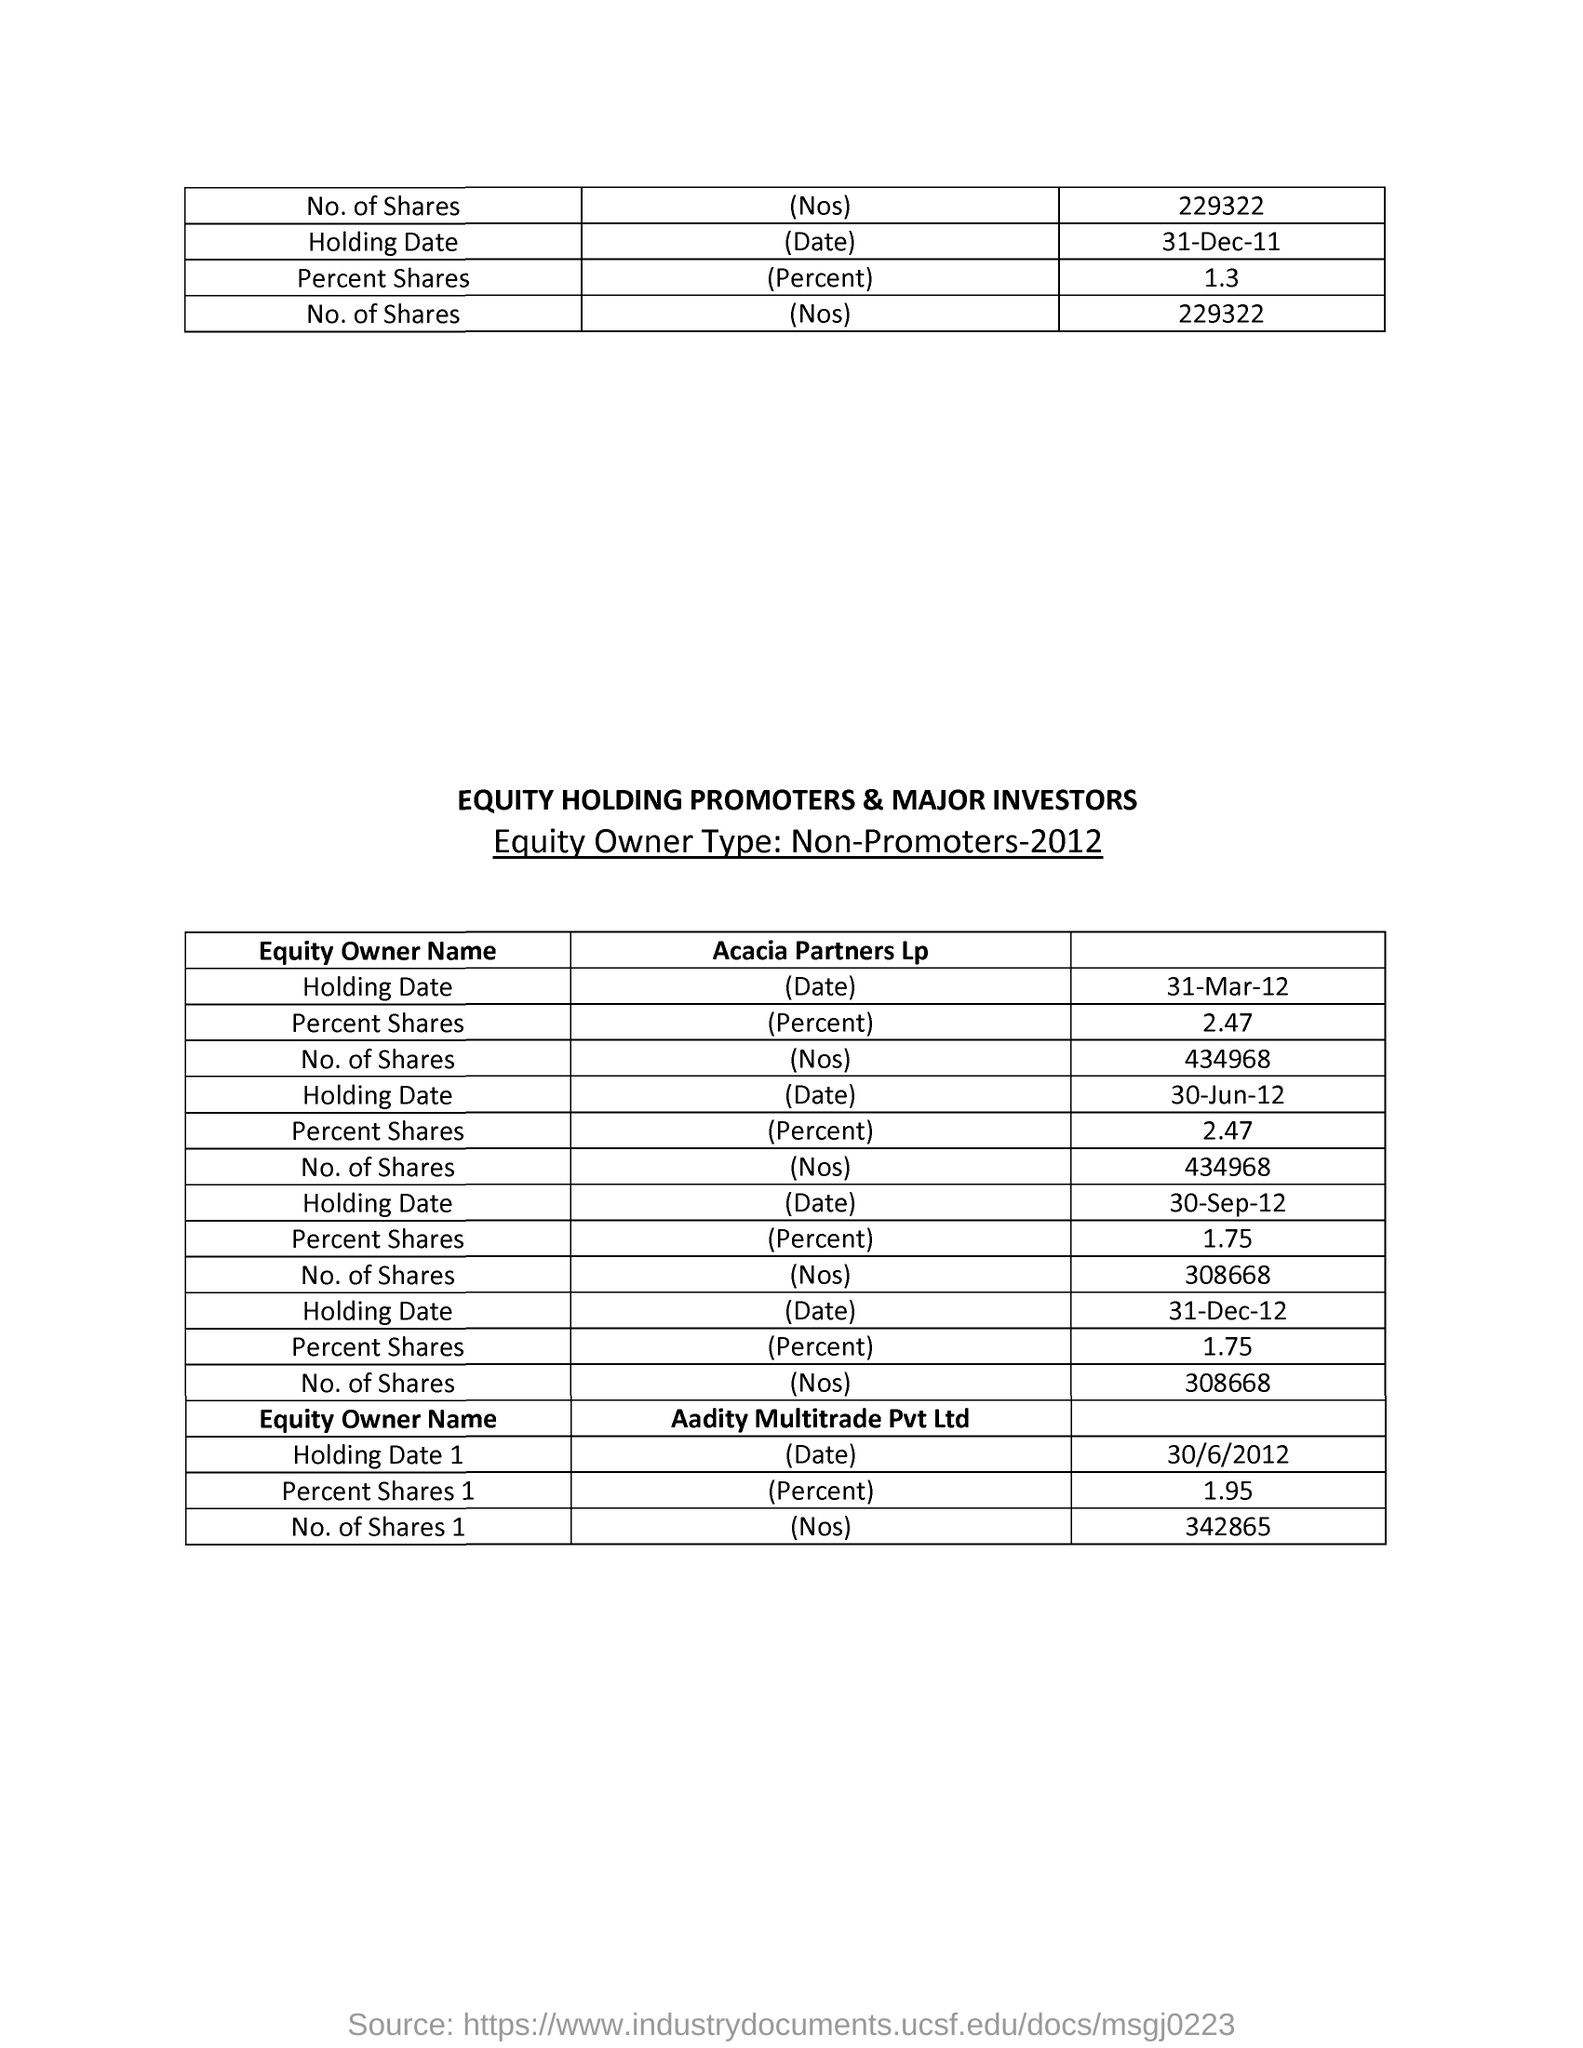Indicate a few pertinent items in this graphic. The equity owner name for shares of 1 with a percentage of 1.95 is "Aadity Multitrade Pvt Ltd". 